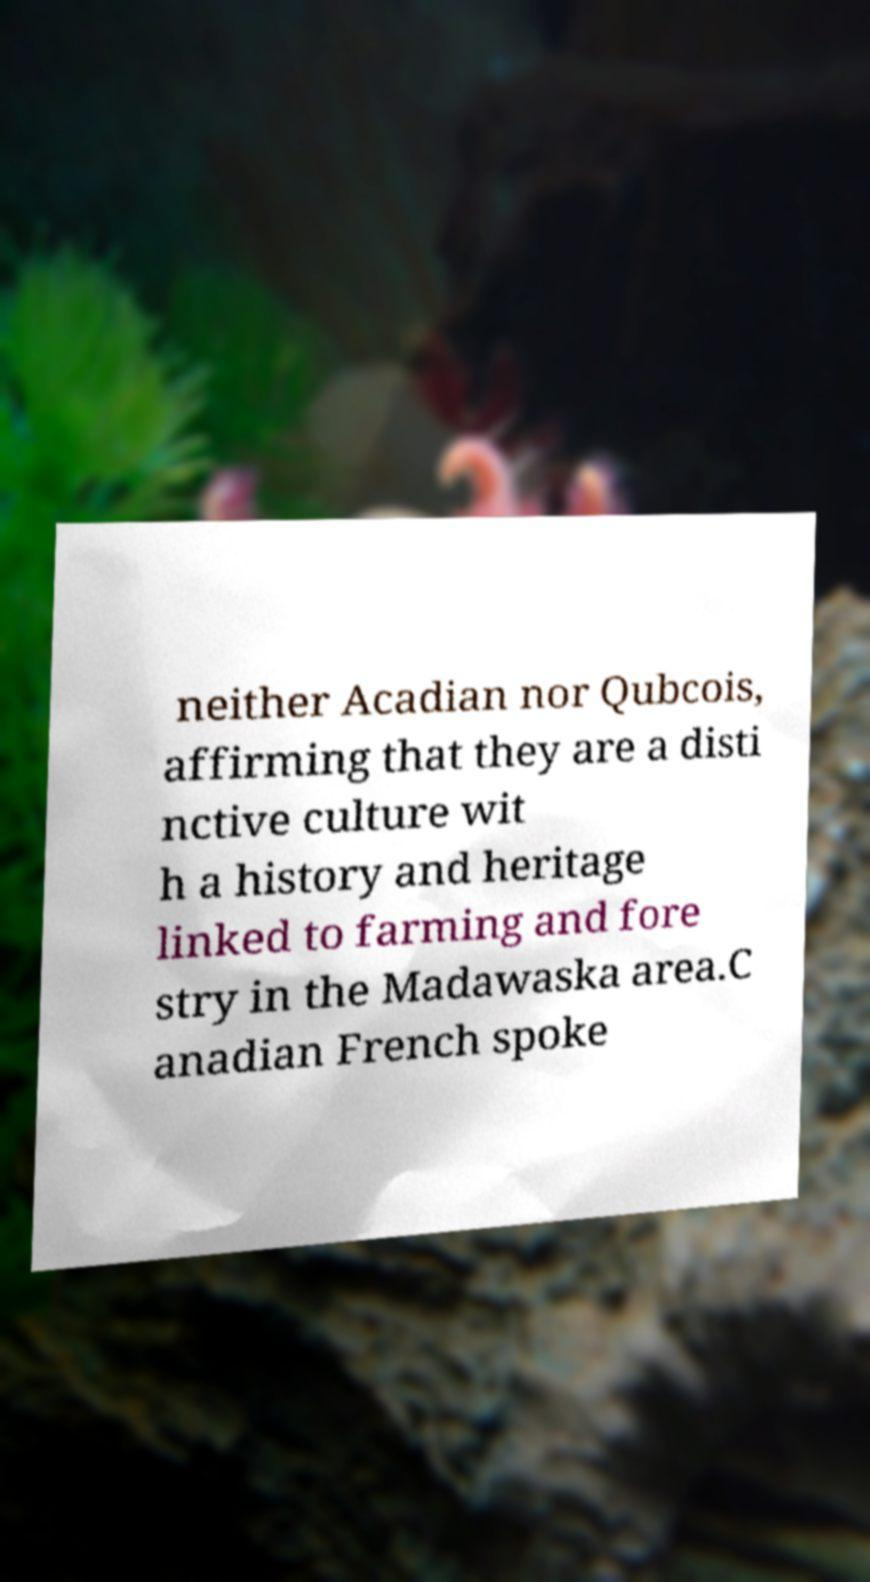For documentation purposes, I need the text within this image transcribed. Could you provide that? neither Acadian nor Qubcois, affirming that they are a disti nctive culture wit h a history and heritage linked to farming and fore stry in the Madawaska area.C anadian French spoke 